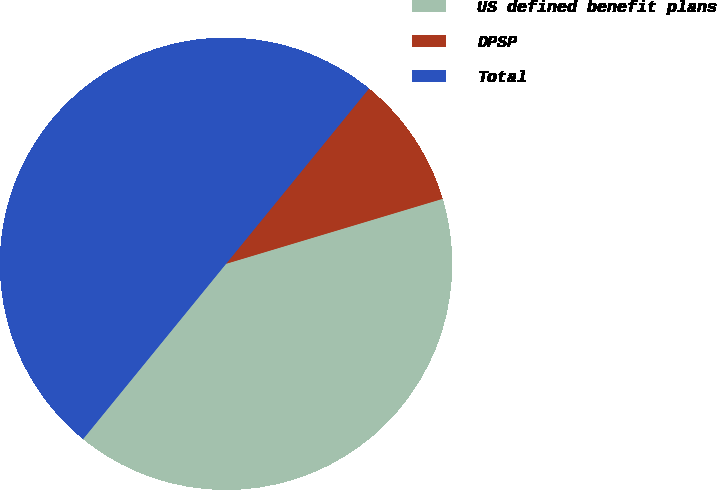<chart> <loc_0><loc_0><loc_500><loc_500><pie_chart><fcel>US defined benefit plans<fcel>DPSP<fcel>Total<nl><fcel>40.53%<fcel>9.47%<fcel>50.0%<nl></chart> 